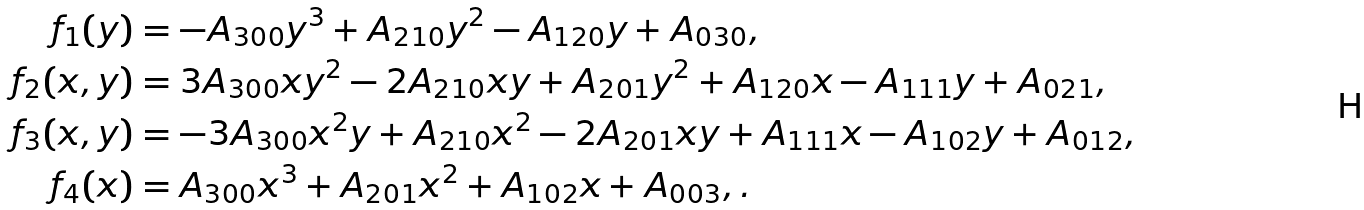Convert formula to latex. <formula><loc_0><loc_0><loc_500><loc_500>f _ { 1 } ( y ) & = - A _ { 3 0 0 } y ^ { 3 } + A _ { 2 1 0 } y ^ { 2 } - A _ { 1 2 0 } y + A _ { 0 3 0 } , \\ f _ { 2 } ( x , y ) & = 3 A _ { 3 0 0 } x y ^ { 2 } - 2 A _ { 2 1 0 } x y + A _ { 2 0 1 } y ^ { 2 } + A _ { 1 2 0 } x - A _ { 1 1 1 } y + A _ { 0 2 1 } , \\ f _ { 3 } ( x , y ) & = - 3 A _ { 3 0 0 } x ^ { 2 } y + A _ { 2 1 0 } x ^ { 2 } - 2 A _ { 2 0 1 } x y + A _ { 1 1 1 } x - A _ { 1 0 2 } y + A _ { 0 1 2 } , \\ f _ { 4 } ( x ) & = A _ { 3 0 0 } x ^ { 3 } + A _ { 2 0 1 } x ^ { 2 } + A _ { 1 0 2 } x + A _ { 0 0 3 } , .</formula> 